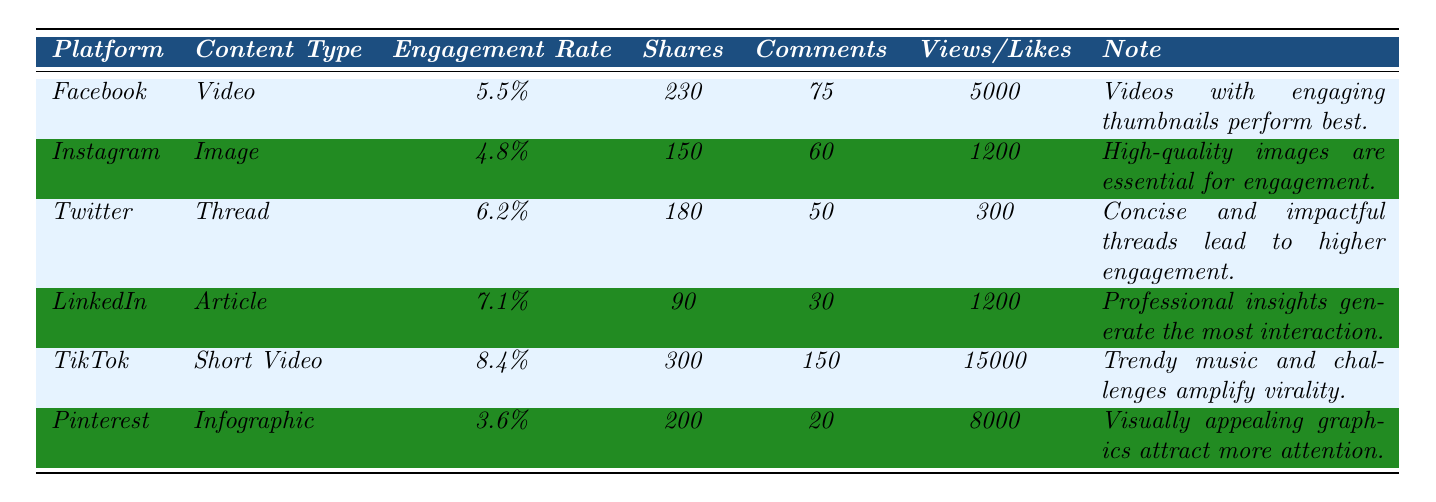What is the average engagement rate for TikTok? According to the table, TikTok has an average engagement rate listed as 8.4%.
Answer: 8.4% Which platform has the highest average comments? From the data, TikTok shows an average of 150 comments, which is higher than the other platforms.
Answer: TikTok How many average shares does Instagram content receive? The table shows that Instagram content receives an average of 150 shares.
Answer: 150 What is the difference in engagement rates between LinkedIn and Facebook? LinkedIn has an engagement rate of 7.1% while Facebook has 5.5%. The difference is calculated as 7.1% - 5.5% = 1.6%.
Answer: 1.6% Which content type on Twitter has a higher engagement rate than Instagram? Twitter's Thread, with an engagement rate of 6.2%, is higher than Instagram's Image at 4.8%.
Answer: Yes What is the average number of likes for the content types listed? The likes are as follows: Instagram (1200), LinkedIn (1200), and TikTok does not list its likes separately but reports views instead. Therefore, the average for the rest would be (1200 + 1200) / 2 = 1200.
Answer: 1200 Is the average engagement rate for Pinterest below 4%? Pinterest has an engagement rate of 3.6%, which is indeed below 4%.
Answer: Yes Which platform has both the highest engagement rate and the most average shares? TikTok has the highest engagement rate of 8.4% and also the most average shares at 300.
Answer: TikTok What is the total number of average comments for all platforms combined? Summing the average comments: Facebook (75) + Instagram (60) + Twitter (50) + LinkedIn (30) + TikTok (150) + Pinterest (20) equals 75 + 60 + 50 + 30 + 150 + 20 = 385.
Answer: 385 Which platform has the lowest average engagement rate? According to the table, Pinterest has the lowest average engagement rate, listed at 3.6%.
Answer: Pinterest 